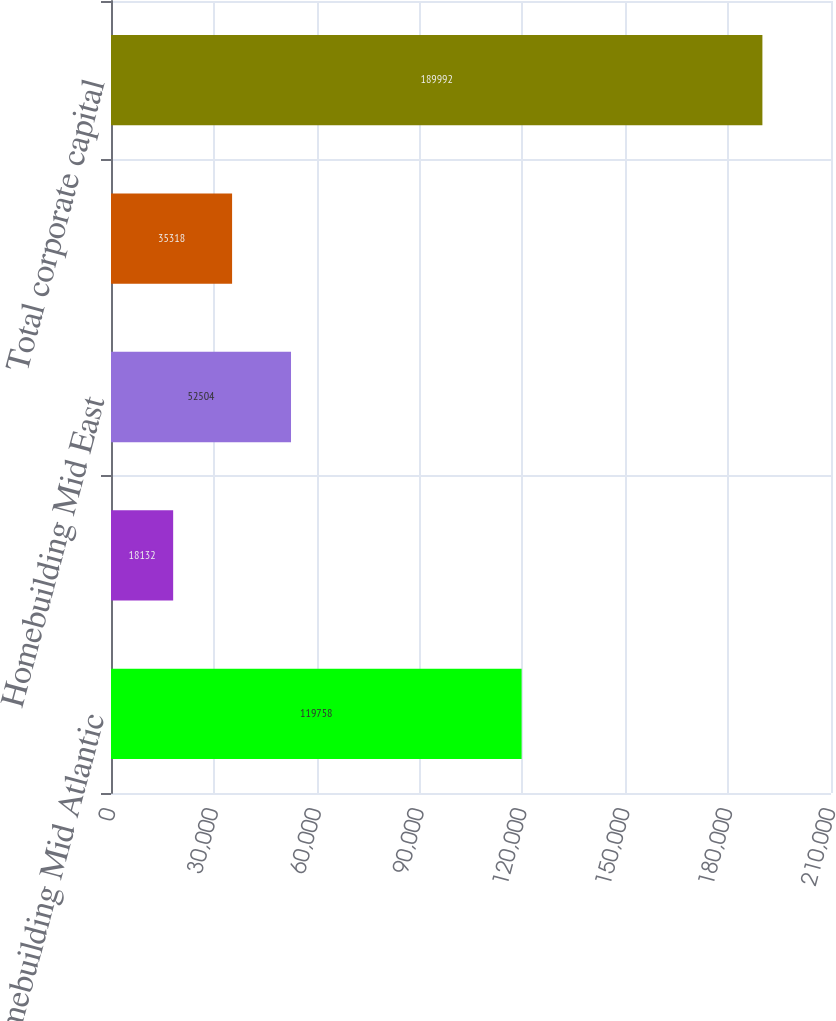<chart> <loc_0><loc_0><loc_500><loc_500><bar_chart><fcel>Homebuilding Mid Atlantic<fcel>Homebuilding North East<fcel>Homebuilding Mid East<fcel>Homebuilding South East<fcel>Total corporate capital<nl><fcel>119758<fcel>18132<fcel>52504<fcel>35318<fcel>189992<nl></chart> 